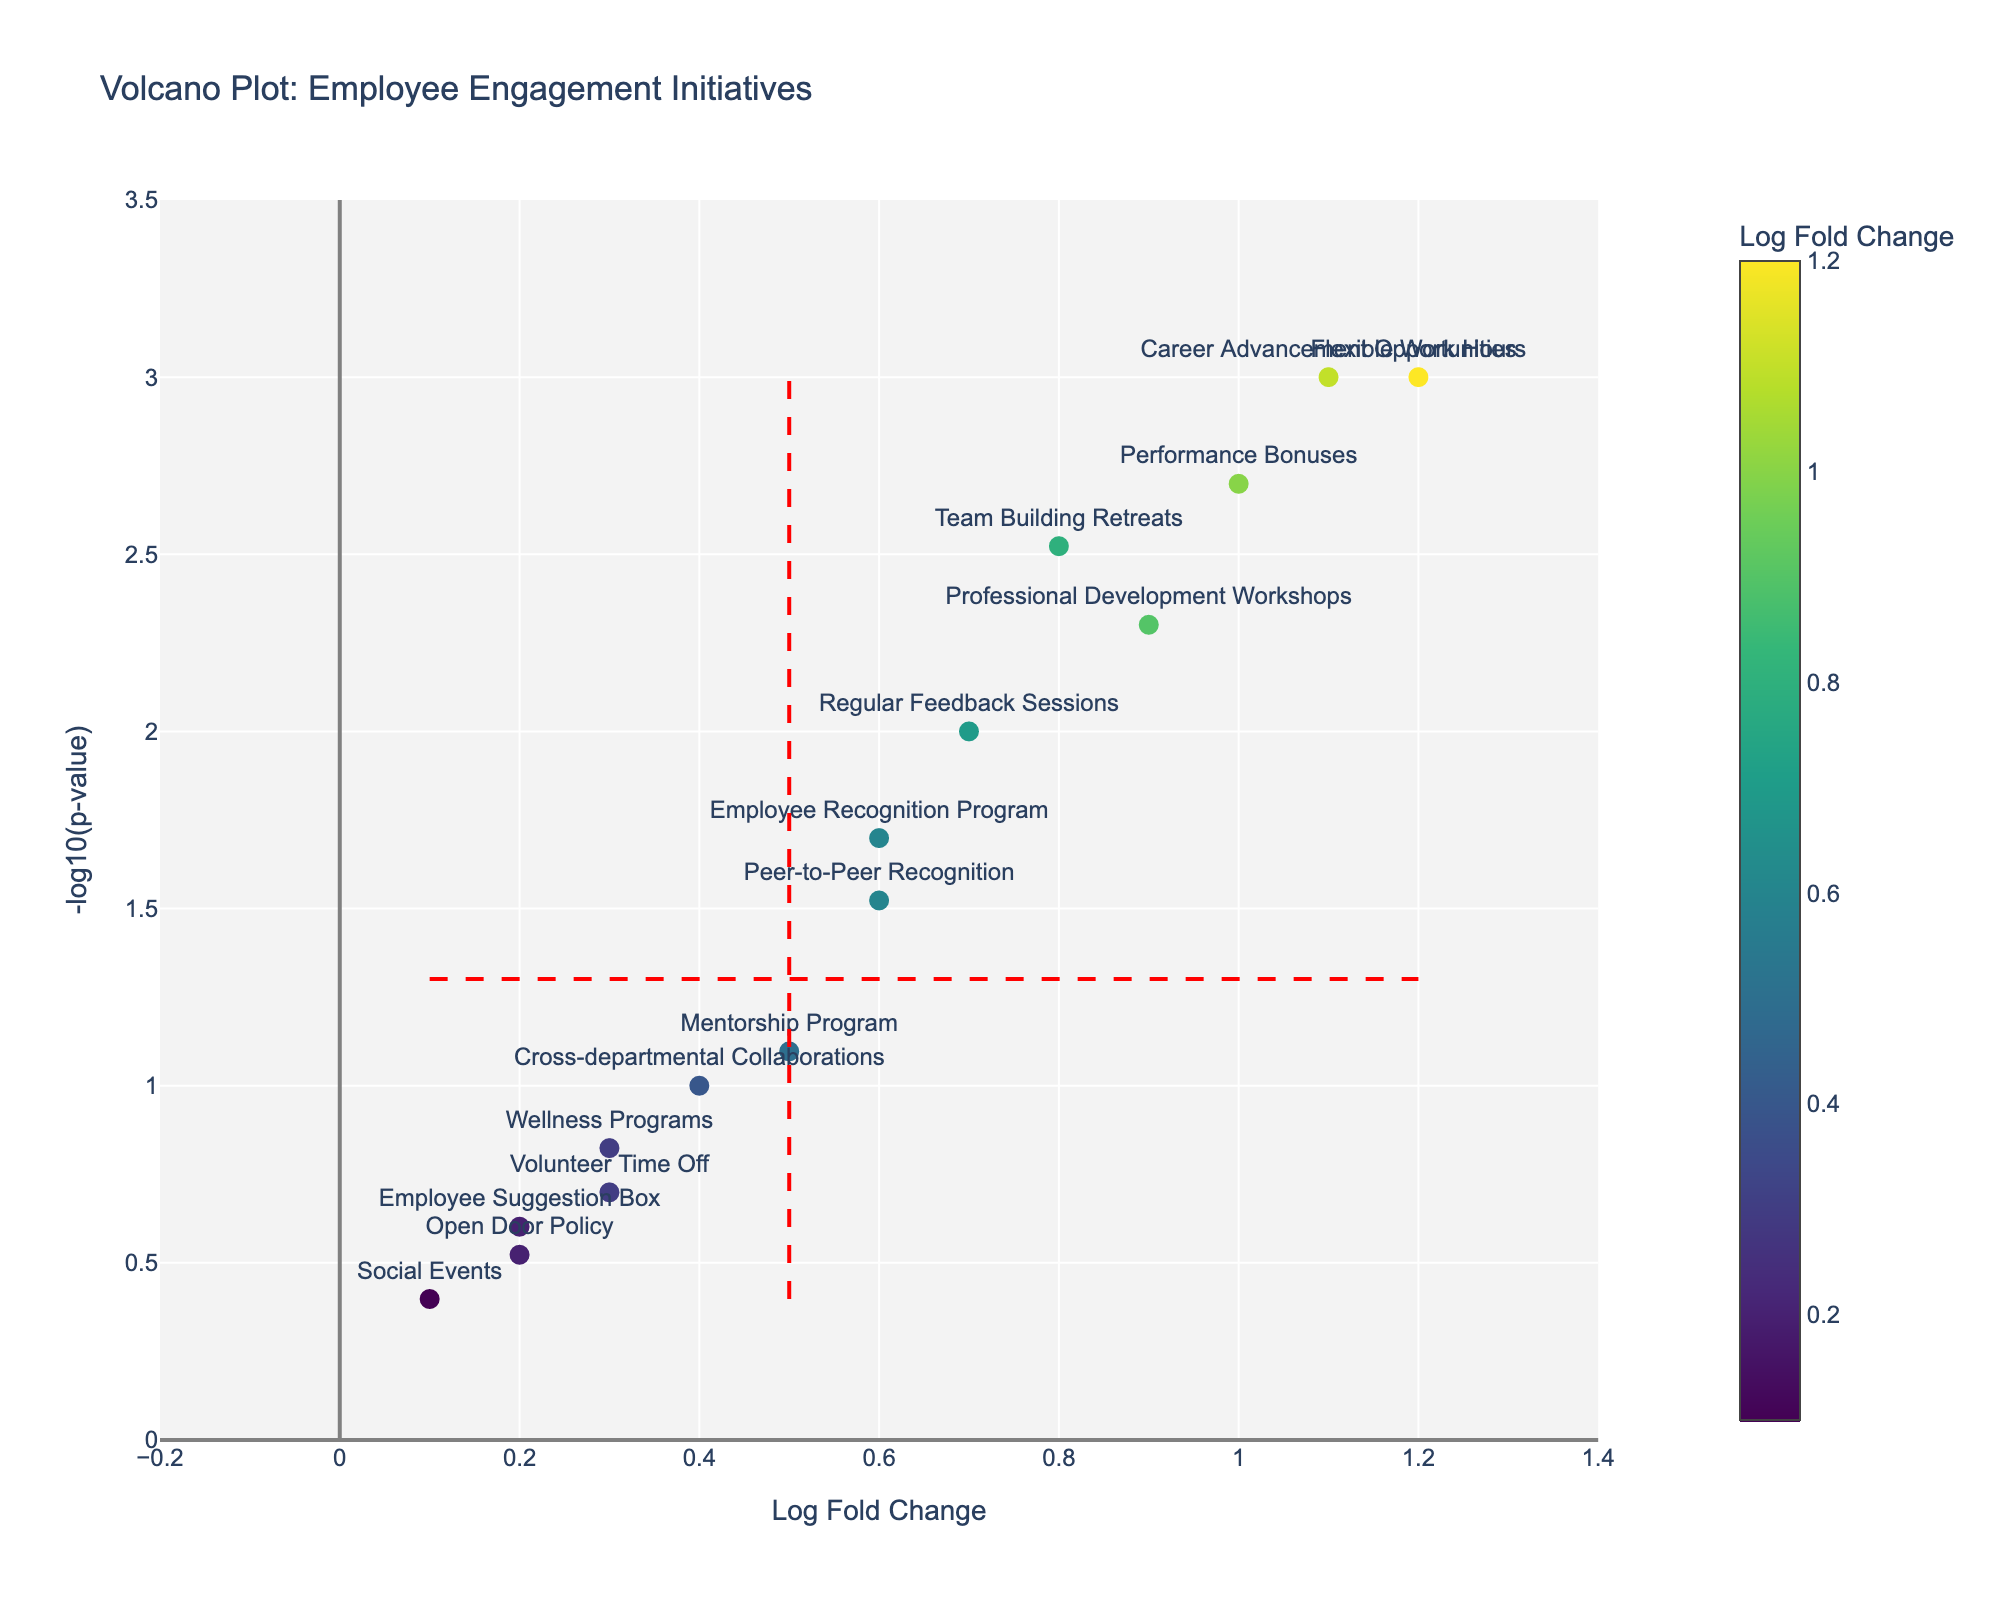What is the title of the figure? The title of the figure is typically displayed prominently at the top and is usually the first thing visible when looking at a plot.
Answer: Volcano Plot: Employee Engagement Initiatives What do the colors on the markers represent? The colors on the markers represent the Log Fold Change values as indicated by the color scale or legend on the plot.
Answer: Log Fold Change How many initiatives have a Log Fold Change greater than 1? By looking at the x-axis, we can see which markers (initiatives) are located to the right of the 1 mark on the Log Fold Change axis.
Answer: 3 Which initiatives fall below the p-value threshold of 0.05? Identify the horizontal red dashed line, which represents the p-value threshold of 0.05 (-log10(p-value) of about 1.301). Count the initiatives above this line.
Answer: All except Wellness Programs, Open Door Policy, Social Events, Volunteer Time Off, Employee Suggestion Box, Peer-to-Peer Recognition, and Cross-departmental Collaborations Which initiative has the highest Log Fold Change? The initiative with the marker positioned farthest to the right on the x-axis has the highest Log Fold Change.
Answer: Flexible Work Hours What is the Log Fold Change and p-value for Regular Feedback Sessions? Locate the Regular Feedback Sessions label on the plot and hover to see the details via the hover text. The Log Fold Change and p-value will be displayed.
Answer: Log Fold Change: 0.7, p-value: 0.01 Among the initiatives with a p-value below 0.01, which one has the smallest Log Fold Change? Identify the markers above the horizontal line (p-value < 0.01), then find the one farthest to the left (indicating the smallest Log Fold Change).
Answer: Team Building Retreats Which initiatives simultaneously maximize Log Fold Change and minimize p-value? These initiatives are typically found towards the top right corner of the plot. Identify the initiatives in this region.
Answer: Flexible Work Hours, Career Advancement Opportunities, Performance Bonuses How many initiatives have a Log Fold Change between 0 and 0.5? Count the number of markers that fall between the 0 and 0.5 marks on the Log Fold Change axis.
Answer: 4 What significance do the red dashed lines hold on the plot? The red dashed lines represent thresholds: the horizontal line indicates the p-value threshold (0.05) and the vertical lines indicate the Log Fold Change thresholds (-0.5 and 0.5).
Answer: p-value and Log Fold Change thresholds 